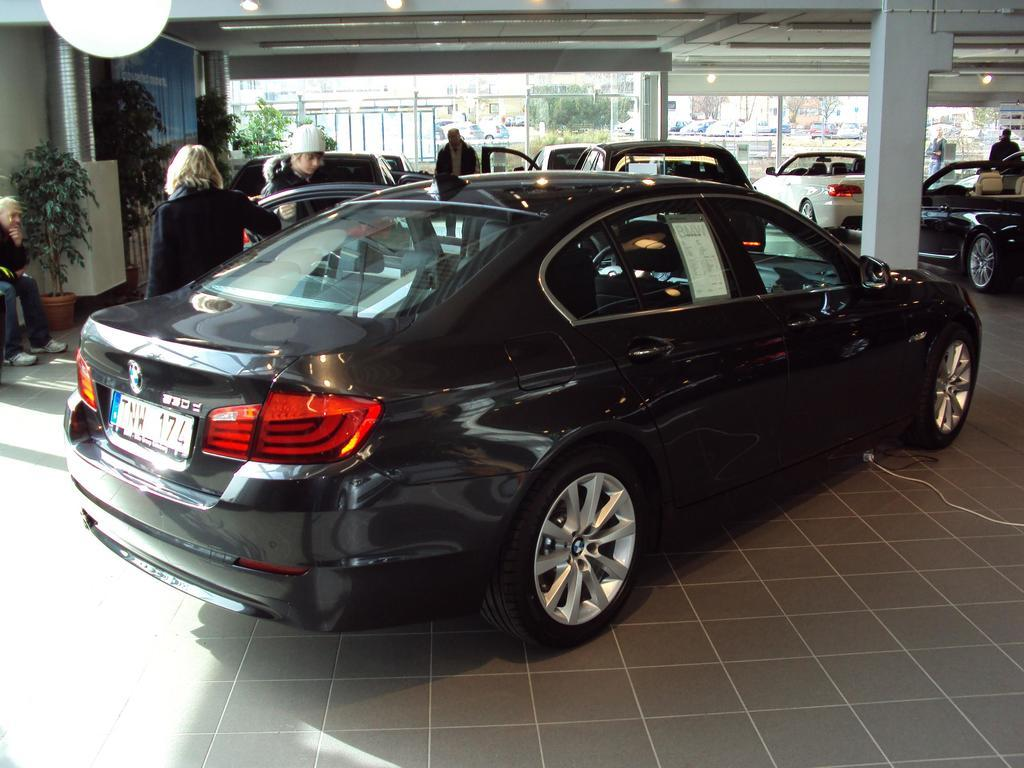What types of objects can be seen in the image? There are vehicles in the image. Can you describe one of the vehicles? One of the vehicles is black. What can be seen in the background of the image? There are people in the background of the image. What are the people in the background doing? Some people are standing, while others are sitting. What type of vegetation is present in the image? There are plants with green color in the image. What type of line can be seen connecting the vehicles in the image? There is no line connecting the vehicles in the image. What kind of bait is being used by the people in the image? There is no fishing or bait-related activity depicted in the image. 